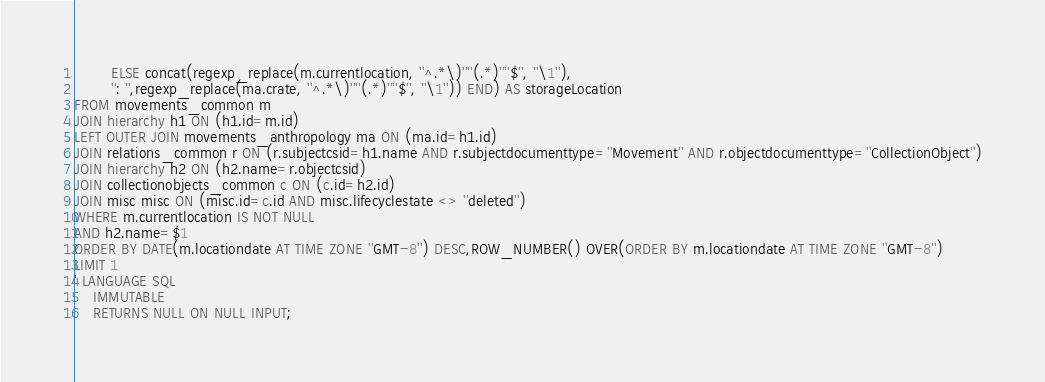<code> <loc_0><loc_0><loc_500><loc_500><_SQL_>        ELSE concat(regexp_replace(m.currentlocation, ''^.*\)''''(.*)''''$'', ''\1''),
        '': '',regexp_replace(ma.crate, ''^.*\)''''(.*)''''$'', ''\1'')) END) AS storageLocation
FROM movements_common m
JOIN hierarchy h1 ON (h1.id=m.id)
LEFT OUTER JOIN movements_anthropology ma ON (ma.id=h1.id)
JOIN relations_common r ON (r.subjectcsid=h1.name AND r.subjectdocumenttype=''Movement'' AND r.objectdocumenttype=''CollectionObject'')
JOIN hierarchy h2 ON (h2.name=r.objectcsid)
JOIN collectionobjects_common c ON (c.id=h2.id)
JOIN misc misc ON (misc.id=c.id AND misc.lifecyclestate <> ''deleted'')
WHERE m.currentlocation IS NOT NULL
AND h2.name=$1
ORDER BY DATE(m.locationdate AT TIME ZONE ''GMT-8'') DESC,ROW_NUMBER() OVER(ORDER BY m.locationdate AT TIME ZONE ''GMT-8'')
LIMIT 1  
' LANGUAGE SQL
    IMMUTABLE
    RETURNS NULL ON NULL INPUT;
</code> 